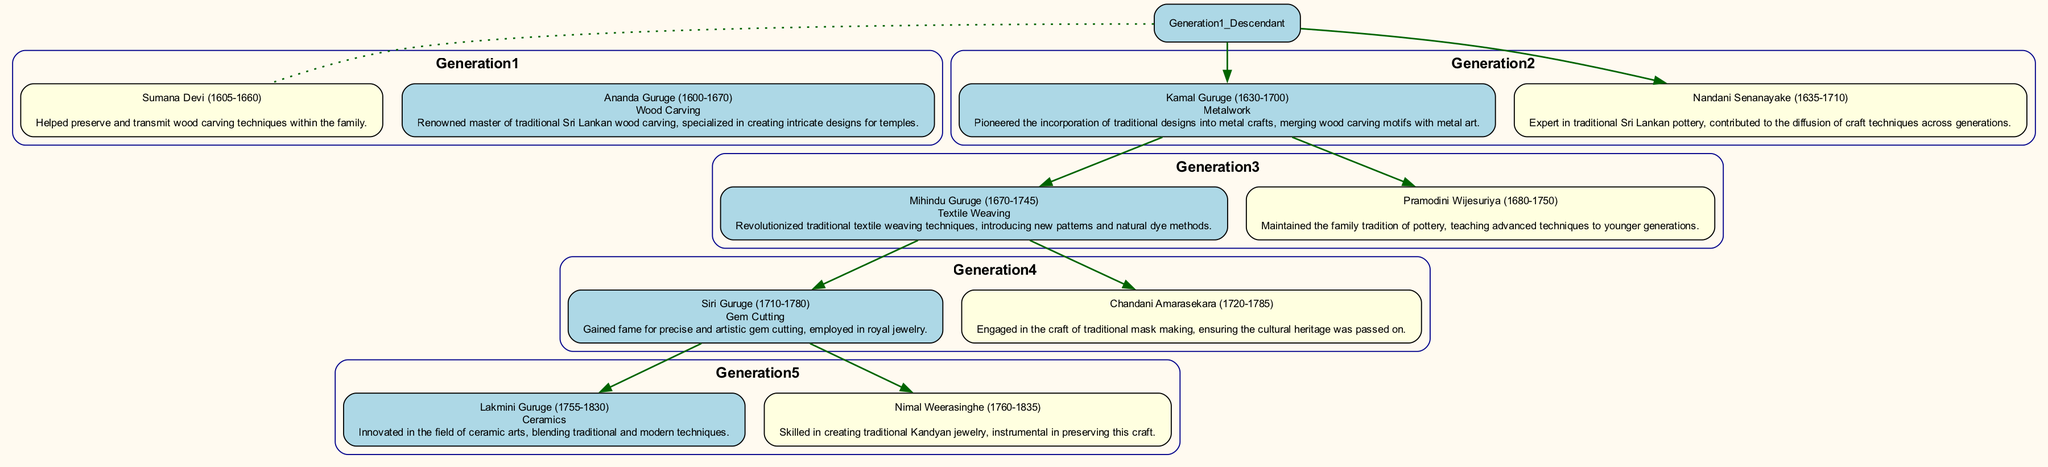What is the craft associated with Ananda Guruge? The diagram specifies that Ananda Guruge's craft is "Wood Carving." This can be directly observed from the information provided about him in the first generation.
Answer: Wood Carving Who is the spouse of Kamal Guruge? According to the diagram, Kamal Guruge's spouse is Nandani Senanayake. This relationship is shown directly through the connections in the second generation.
Answer: Nandani Senanayake What year was Lakmini Guruge born? The information in the diagram shows that Lakmini Guruge was born in the year 1755. This is directly available from the details listed in the fifth generation.
Answer: 1755 How many generations are represented in the diagram? By examining the structure of the family tree, it is noted that there are five distinct generations depicted. This can be counted from Generation 1 through Generation 5.
Answer: 5 Which craft did Mihindu Guruge revolutionize? The diagram indicates that Mihindu Guruge revolutionized "Textile Weaving" techniques. This information is specifically stated in his details within the third generation.
Answer: Textile Weaving What is the relationship between Siri Guruge and Kamal Guruge? Siri Guruge is the grandson of Kamal Guruge, as shown in the family tree structure where each descendant is connected to the previous generation. This reasoning includes the lineage connections in the diagram.
Answer: Grandson How many spouse nodes are there in the diagram? Upon reviewing the whole diagram, there are four spouse nodes listed, each connected to their respective descendant. This counts the spouses of each generation from Generation 2 to Generation 5.
Answer: 4 What craft does Chandani Amarasekara uphold? The diagram states that Chandani Amarasekara is engaged in the craft of "traditional mask making," which is specifically mentioned in her description under Generation 4.
Answer: traditional mask making Which descendant was born in 1680? Referring to the diagram, Pramodini Wijesuriya was born in 1680, as indicated in the details listed under Generation 3.
Answer: Pramodini Wijesuriya 